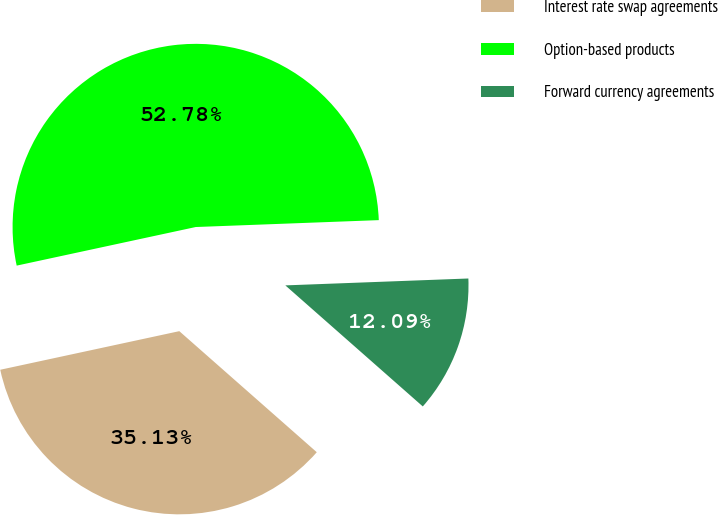Convert chart. <chart><loc_0><loc_0><loc_500><loc_500><pie_chart><fcel>Interest rate swap agreements<fcel>Option-based products<fcel>Forward currency agreements<nl><fcel>35.13%<fcel>52.78%<fcel>12.09%<nl></chart> 